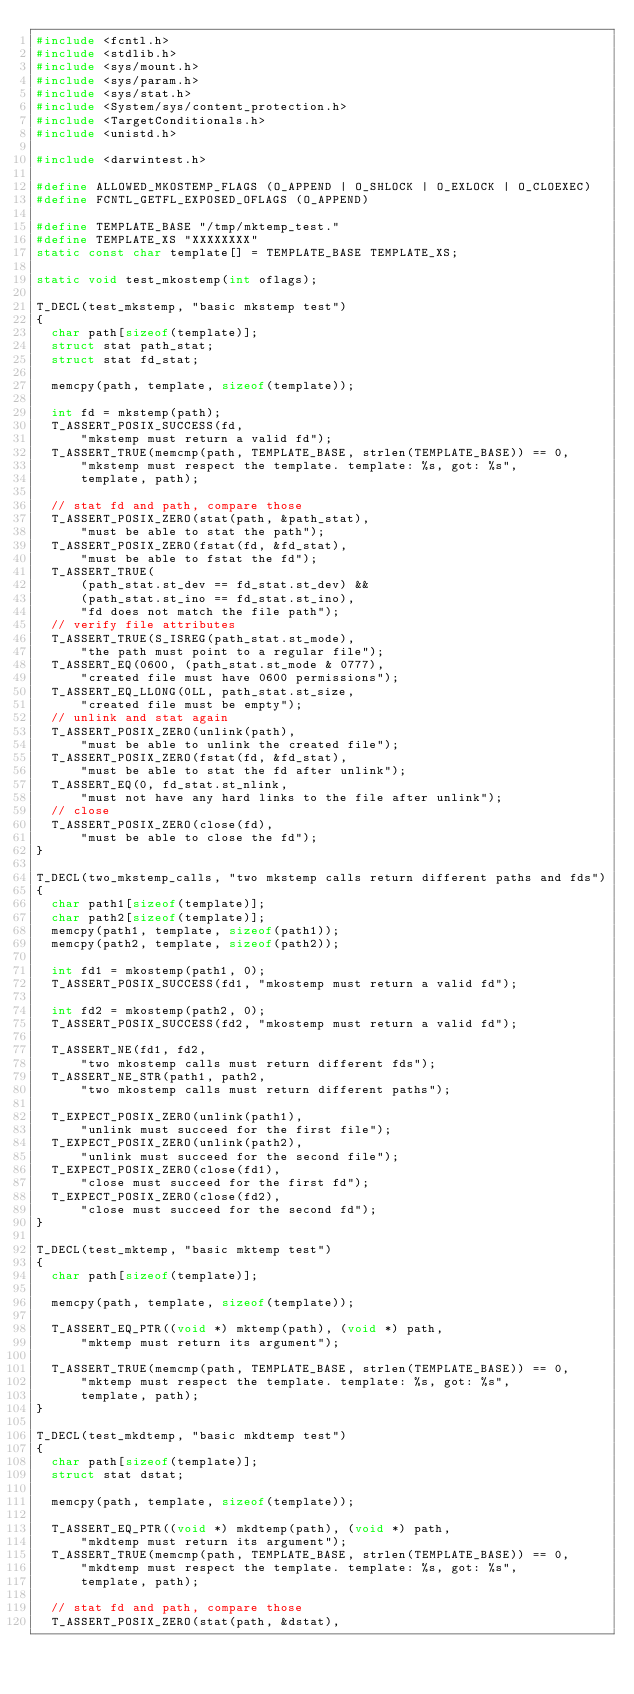<code> <loc_0><loc_0><loc_500><loc_500><_C_>#include <fcntl.h>
#include <stdlib.h>
#include <sys/mount.h>
#include <sys/param.h>
#include <sys/stat.h>
#include <System/sys/content_protection.h>
#include <TargetConditionals.h>
#include <unistd.h>

#include <darwintest.h>

#define ALLOWED_MKOSTEMP_FLAGS (O_APPEND | O_SHLOCK | O_EXLOCK | O_CLOEXEC)
#define FCNTL_GETFL_EXPOSED_OFLAGS (O_APPEND)

#define TEMPLATE_BASE "/tmp/mktemp_test."
#define TEMPLATE_XS "XXXXXXXX"
static const char template[] = TEMPLATE_BASE TEMPLATE_XS;

static void test_mkostemp(int oflags);

T_DECL(test_mkstemp, "basic mkstemp test")
{
	char path[sizeof(template)];
	struct stat path_stat;
	struct stat fd_stat;

	memcpy(path, template, sizeof(template));

	int fd = mkstemp(path);
	T_ASSERT_POSIX_SUCCESS(fd,
			"mkstemp must return a valid fd");
	T_ASSERT_TRUE(memcmp(path, TEMPLATE_BASE, strlen(TEMPLATE_BASE)) == 0,
			"mkstemp must respect the template. template: %s, got: %s",
			template, path);

	// stat fd and path, compare those
	T_ASSERT_POSIX_ZERO(stat(path, &path_stat),
			"must be able to stat the path");
	T_ASSERT_POSIX_ZERO(fstat(fd, &fd_stat),
			"must be able to fstat the fd");
	T_ASSERT_TRUE(
			(path_stat.st_dev == fd_stat.st_dev) &&
			(path_stat.st_ino == fd_stat.st_ino),
			"fd does not match the file path");
	// verify file attributes
	T_ASSERT_TRUE(S_ISREG(path_stat.st_mode),
			"the path must point to a regular file");
	T_ASSERT_EQ(0600, (path_stat.st_mode & 0777),
			"created file must have 0600 permissions");
	T_ASSERT_EQ_LLONG(0LL, path_stat.st_size,
			"created file must be empty");
	// unlink and stat again
	T_ASSERT_POSIX_ZERO(unlink(path),
			"must be able to unlink the created file");
	T_ASSERT_POSIX_ZERO(fstat(fd, &fd_stat),
			"must be able to stat the fd after unlink");
	T_ASSERT_EQ(0, fd_stat.st_nlink,
			"must not have any hard links to the file after unlink");
	// close
	T_ASSERT_POSIX_ZERO(close(fd),
			"must be able to close the fd");
}

T_DECL(two_mkstemp_calls, "two mkstemp calls return different paths and fds")
{
	char path1[sizeof(template)];
	char path2[sizeof(template)];
	memcpy(path1, template, sizeof(path1));
	memcpy(path2, template, sizeof(path2));

	int fd1 = mkostemp(path1, 0);
	T_ASSERT_POSIX_SUCCESS(fd1, "mkostemp must return a valid fd");

	int fd2 = mkostemp(path2, 0);
	T_ASSERT_POSIX_SUCCESS(fd2, "mkostemp must return a valid fd");

	T_ASSERT_NE(fd1, fd2,
			"two mkostemp calls must return different fds");
	T_ASSERT_NE_STR(path1, path2,
			"two mkostemp calls must return different paths");

	T_EXPECT_POSIX_ZERO(unlink(path1),
			"unlink must succeed for the first file");
	T_EXPECT_POSIX_ZERO(unlink(path2),
			"unlink must succeed for the second file");
	T_EXPECT_POSIX_ZERO(close(fd1),
			"close must succeed for the first fd");
	T_EXPECT_POSIX_ZERO(close(fd2),
			"close must succeed for the second fd");
}

T_DECL(test_mktemp, "basic mktemp test")
{
	char path[sizeof(template)];

	memcpy(path, template, sizeof(template));

	T_ASSERT_EQ_PTR((void *) mktemp(path), (void *) path,
			"mktemp must return its argument");

	T_ASSERT_TRUE(memcmp(path, TEMPLATE_BASE, strlen(TEMPLATE_BASE)) == 0,
			"mktemp must respect the template. template: %s, got: %s",
			template, path);
}

T_DECL(test_mkdtemp, "basic mkdtemp test")
{
	char path[sizeof(template)];
	struct stat dstat;

	memcpy(path, template, sizeof(template));

	T_ASSERT_EQ_PTR((void *) mkdtemp(path), (void *) path,
			"mkdtemp must return its argument");
	T_ASSERT_TRUE(memcmp(path, TEMPLATE_BASE, strlen(TEMPLATE_BASE)) == 0,
			"mkdtemp must respect the template. template: %s, got: %s",
			template, path);

	// stat fd and path, compare those
	T_ASSERT_POSIX_ZERO(stat(path, &dstat),</code> 